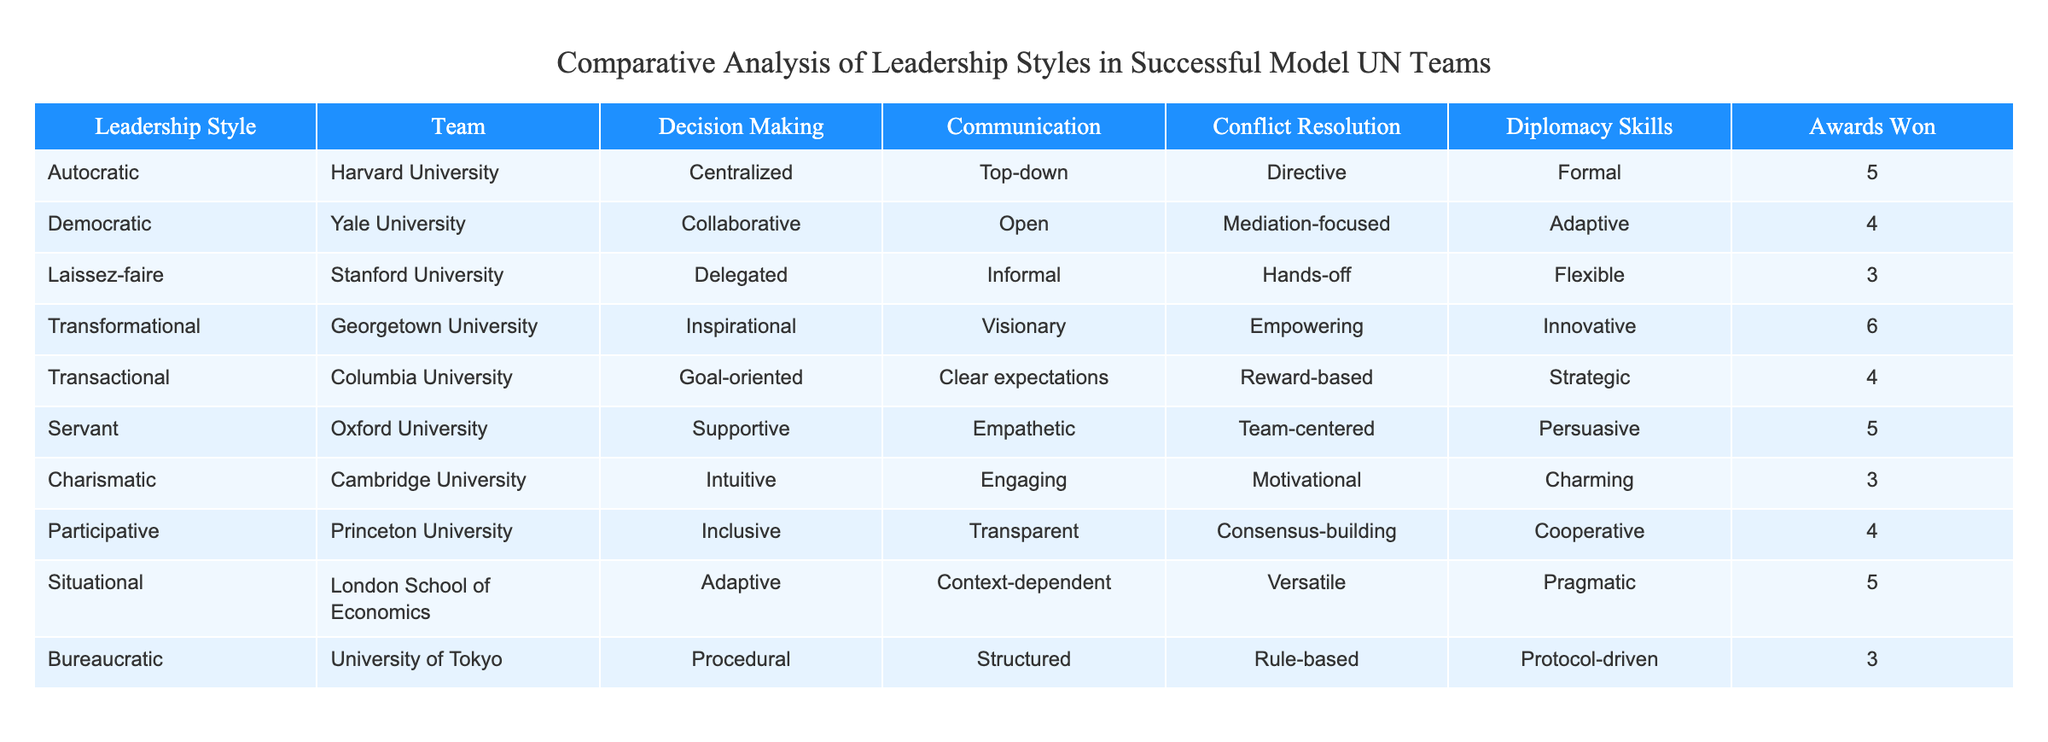What leadership style corresponds to the highest number of awards won? By looking at the "Awards Won" column, we see that the "Transformational" leadership style from Georgetown University has the highest total with 6 awards. No other leadership style has more than this.
Answer: Transformational Which team utilizes a participative leadership style? The "Participative" leadership style corresponds to "Princeton University." This information is directly listed in the table.
Answer: Princeton University What is the difference in awards won between the "Autocratic" and "Laissez-faire" styles? The "Autocratic" style has 5 awards, while the "Laissez-faire" style has 3 awards. The difference is 5 - 3 = 2 awards.
Answer: 2 Is the "Bureaucratic" style associated with a high number of awards? No, the "Bureaucratic" style has only 3 awards, which is on the lower end compared to other styles listed.
Answer: No Which leadership styles have won 4 awards? The "Democratic," "Transactional," and "Participative" styles have each won 4 awards. We can find this by checking the "Awards Won" column for the value of 4.
Answer: Democratic, Transactional, Participative What is the average number of awards won by the teams using "Supportive" or "Empowering" styles? The "Supportive" style, represented by Oxford University, has 5 awards, and the "Empowering" style, part of the "Transformational" category from Georgetown University, has 6 awards. The average is (5 + 6) / 2 = 5.5.
Answer: 5.5 Which style has the least awards, and how many? The "Charismatic," "Laissez-faire," and "Bureaucratic" styles all have the least awards, with each totaling 3 awards. The minimum value in the "Awards Won" column is 3.
Answer: 3 Which leadership style is characterized by "Empowering" diplomacy skills? The "Transformational" leadership style exhibits "Empowering" diplomacy skills according to the table. This is derived directly from the "Diplomacy Skills" column entry.
Answer: Transformational How many styles have "Adaptive" in their decision-making approach? Both the "Transformational" and "Situational" styles have "Adaptive" listed as their decision-making approach. Counting these entries provides the answer of 2 styles.
Answer: 2 